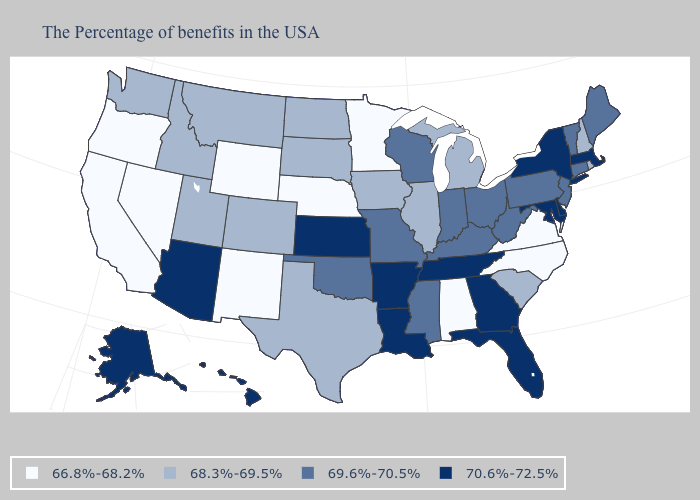Which states hav the highest value in the South?
Answer briefly. Delaware, Maryland, Florida, Georgia, Tennessee, Louisiana, Arkansas. Name the states that have a value in the range 69.6%-70.5%?
Write a very short answer. Maine, Vermont, Connecticut, New Jersey, Pennsylvania, West Virginia, Ohio, Kentucky, Indiana, Wisconsin, Mississippi, Missouri, Oklahoma. Name the states that have a value in the range 69.6%-70.5%?
Write a very short answer. Maine, Vermont, Connecticut, New Jersey, Pennsylvania, West Virginia, Ohio, Kentucky, Indiana, Wisconsin, Mississippi, Missouri, Oklahoma. Is the legend a continuous bar?
Quick response, please. No. What is the value of Alabama?
Short answer required. 66.8%-68.2%. What is the value of Arizona?
Be succinct. 70.6%-72.5%. Does Oregon have the highest value in the USA?
Answer briefly. No. Does the map have missing data?
Keep it brief. No. What is the highest value in the USA?
Concise answer only. 70.6%-72.5%. Does Louisiana have a lower value than Florida?
Give a very brief answer. No. Which states have the lowest value in the MidWest?
Answer briefly. Minnesota, Nebraska. Does Utah have a lower value than Nebraska?
Short answer required. No. Does Idaho have the same value as Wyoming?
Quick response, please. No. Is the legend a continuous bar?
Answer briefly. No. What is the value of Mississippi?
Answer briefly. 69.6%-70.5%. 